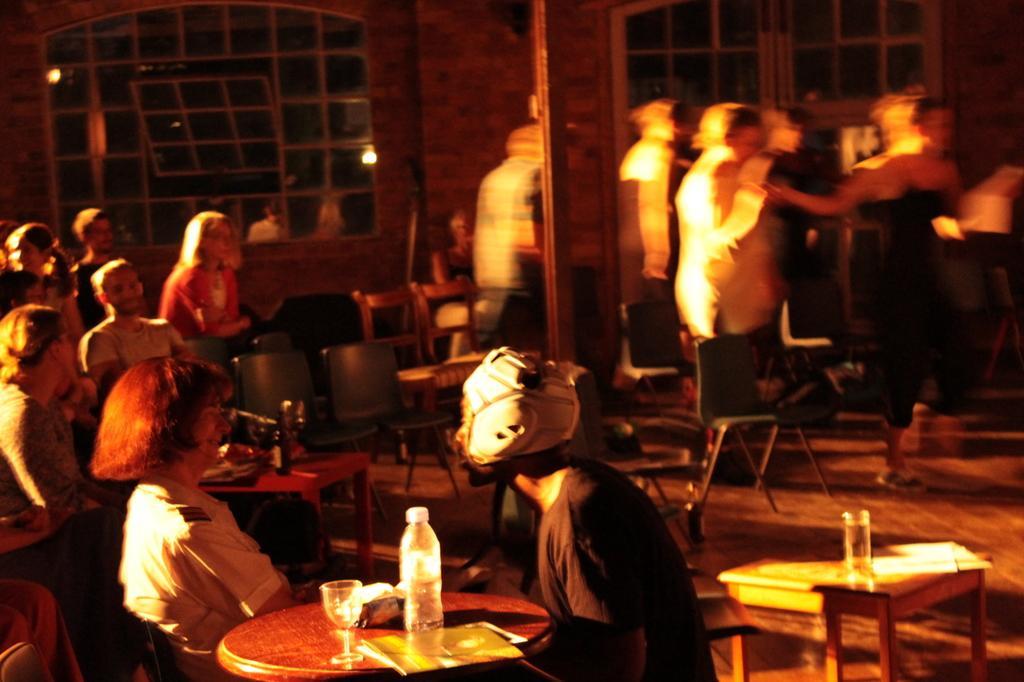Can you describe this image briefly? In the image we can see there are people sitting on chair and there are wine glass and water bottle on the table. 